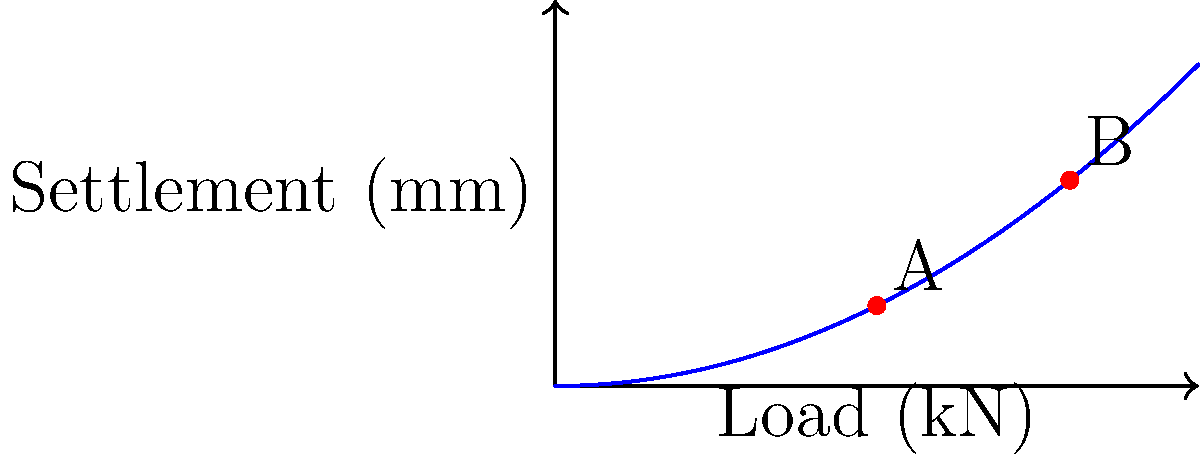In your latest book club meeting, your grandfather presents a fascinating graph from a civil engineering journal, showing the relationship between load and settlement for a particular foundation. If the settlement at point A is 1.25 mm under a 5 kN load, what would be the approximate settlement at point B under an 8 kN load? Assume the relationship follows a quadratic curve. Let's approach this step-by-step:

1) The graph shows a quadratic relationship between load and settlement. We can express this as:

   $S = k \cdot L^2$

   Where $S$ is settlement, $L$ is load, and $k$ is a constant.

2) We're given that at point A:
   Load $(L_A) = 5$ kN
   Settlement $(S_A) = 1.25$ mm

3) Let's find the constant $k$:

   $1.25 = k \cdot 5^2$
   $1.25 = k \cdot 25$
   $k = \frac{1.25}{25} = 0.05$

4) Now we have our equation:

   $S = 0.05 \cdot L^2$

5) For point B, the load $(L_B)$ is 8 kN. Let's calculate the settlement:

   $S_B = 0.05 \cdot 8^2$
   $S_B = 0.05 \cdot 64$
   $S_B = 3.2$ mm

Therefore, the settlement at point B under an 8 kN load would be approximately 3.2 mm.
Answer: 3.2 mm 